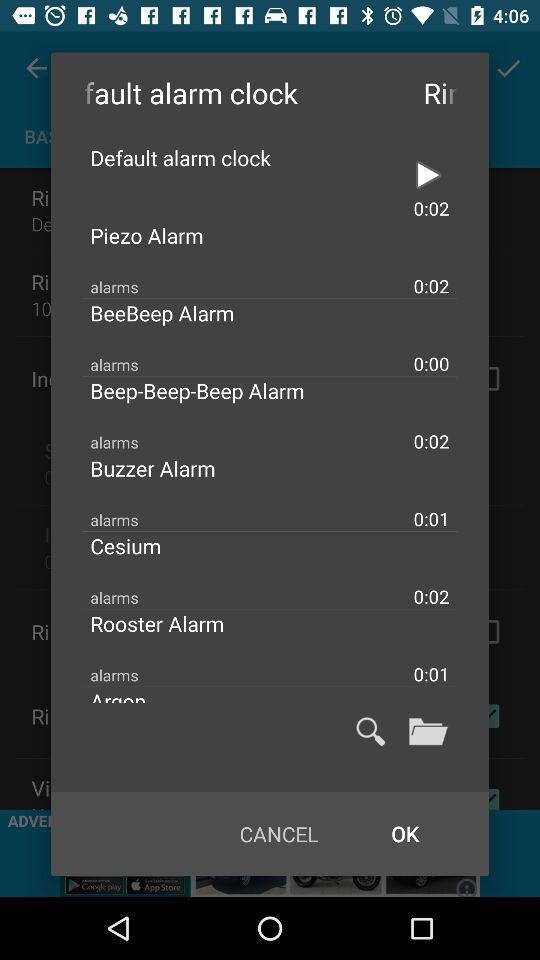What's the duration of the rooster alarm? The duration of the rooster alarm is 0:02. 